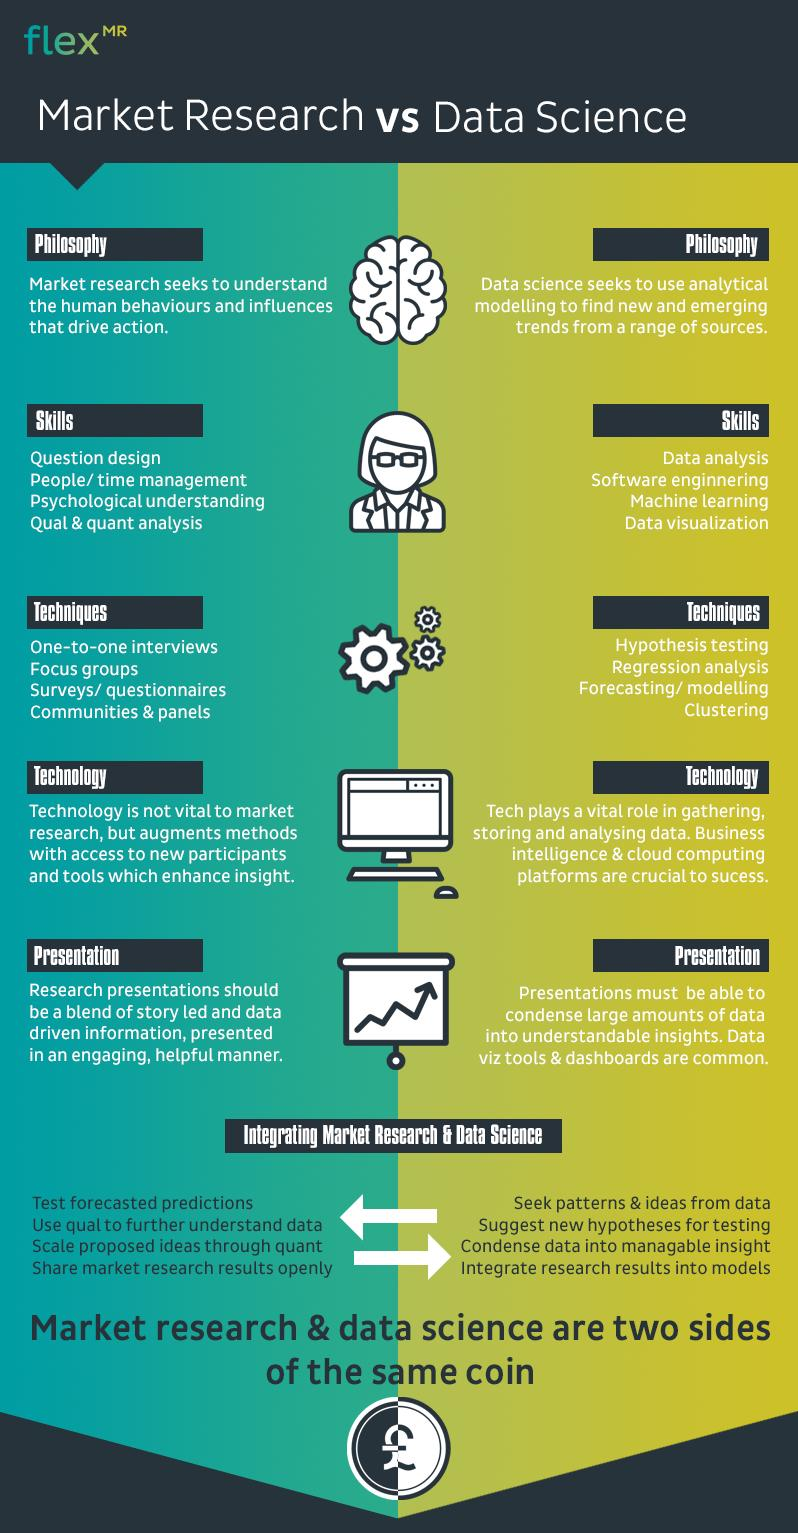Draw attention to some important aspects in this diagram. Regression analysis is the second technique commonly used in the field of data science. There are four points listed under the heading "Skills" in Market Research. In the market research field, the second most important skill needed is people/time management. Focus groups are the second technique commonly used in the field of Market Research. Machine learning is the third essential skill required in the data science field. 